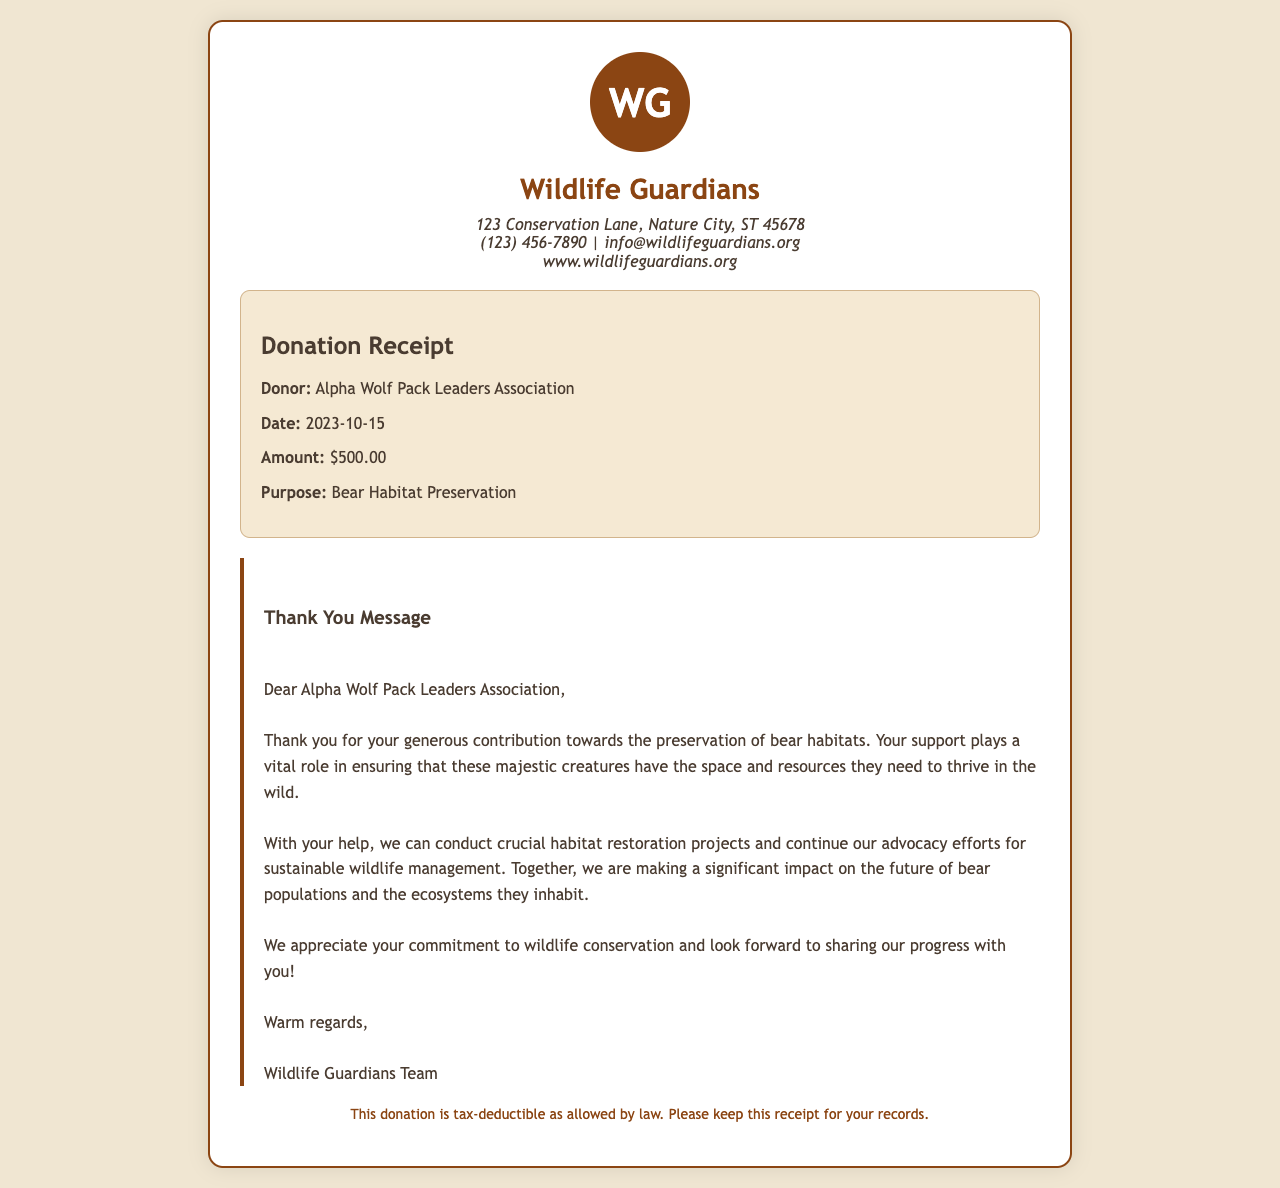What is the name of the organization? The organization is called "Wildlife Guardians," as stated at the top of the receipt.
Answer: Wildlife Guardians What was the donation amount? The donation amount is specified in the donation details section as $500.00.
Answer: $500.00 When was the donation made? The date of the donation is provided under the donation details as 2023-10-15.
Answer: 2023-10-15 Who made the donation? The recipient of the donation is mentioned as "Alpha Wolf Pack Leaders Association."
Answer: Alpha Wolf Pack Leaders Association What is the purpose of the donation? The purpose of the donation is indicated as "Bear Habitat Preservation."
Answer: Bear Habitat Preservation What is included in the thank you message? The thank you message expresses appreciation for the donation and emphasizes the importance of the support for bear habitat preservation.
Answer: Appreciation for the donation What does the footer state about the donation? The footer mentions that the donation is tax-deductible and advises to keep the receipt for records.
Answer: Tax-deductible What vital role does the contribution play? The contribution plays a vital role in ensuring that bear habitats have the space and resources needed to thrive.
Answer: Vital role in thriving Who signed the thank you message? The thank you message is signed by "Wildlife Guardians Team."
Answer: Wildlife Guardians Team 